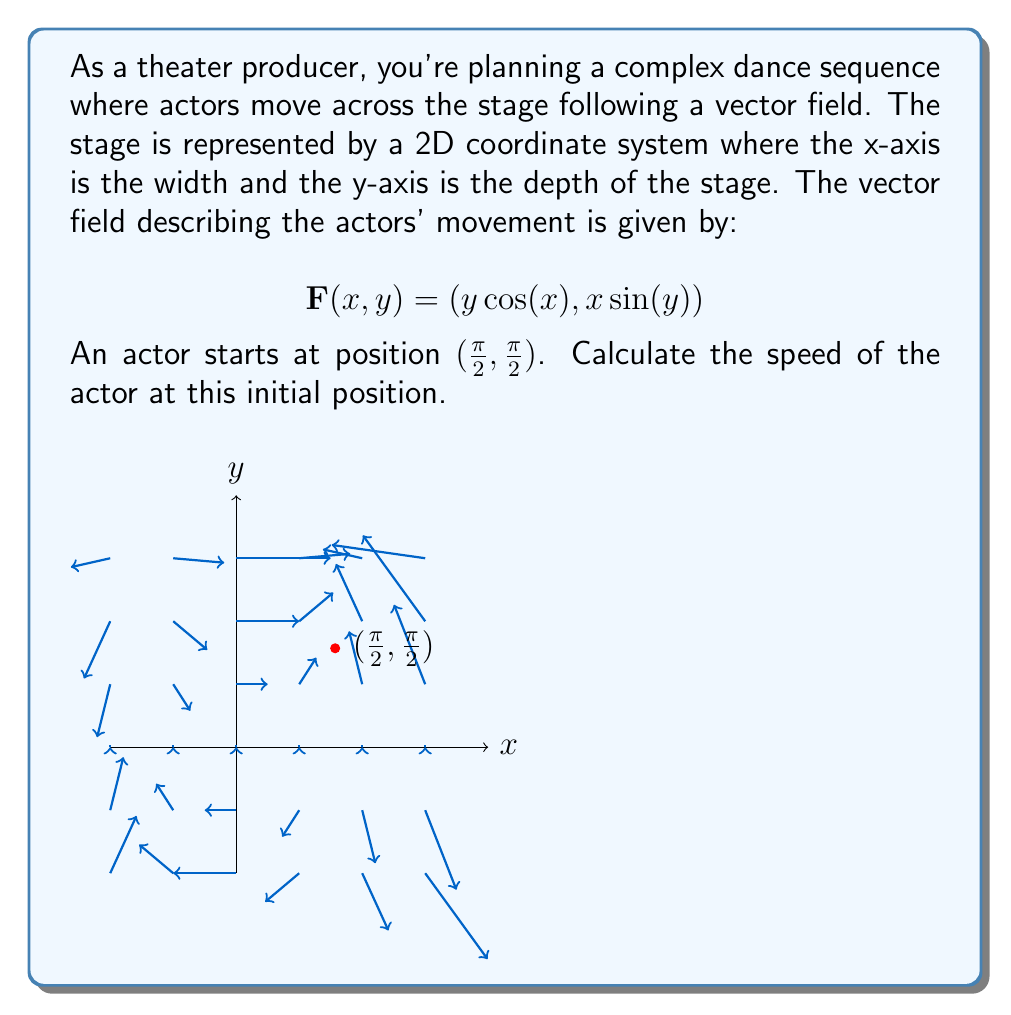Help me with this question. Let's approach this step-by-step:

1) The vector field is given by $\mathbf{F}(x,y) = (y\cos(x), x\sin(y))$.

2) The speed of an object in a vector field at any point is given by the magnitude of the vector at that point.

3) The actor's initial position is (π/2, π/2). We need to evaluate $\mathbf{F}(π/2, π/2)$:

   $\mathbf{F}(π/2, π/2) = ((π/2)\cos(π/2), (π/2)\sin(π/2))$

4) Simplify:
   $\cos(π/2) = 0$ and $\sin(π/2) = 1$

   So, $\mathbf{F}(π/2, π/2) = (0, π/2)$

5) The magnitude of this vector gives the speed. For a vector $(a,b)$, the magnitude is $\sqrt{a^2 + b^2}$.

6) Therefore, the speed is:

   $\sqrt{0^2 + (π/2)^2} = \sqrt{(π/2)^2} = π/2$

Thus, the speed of the actor at the initial position (π/2, π/2) is π/2 units per time unit.
Answer: $π/2$ units per time unit 